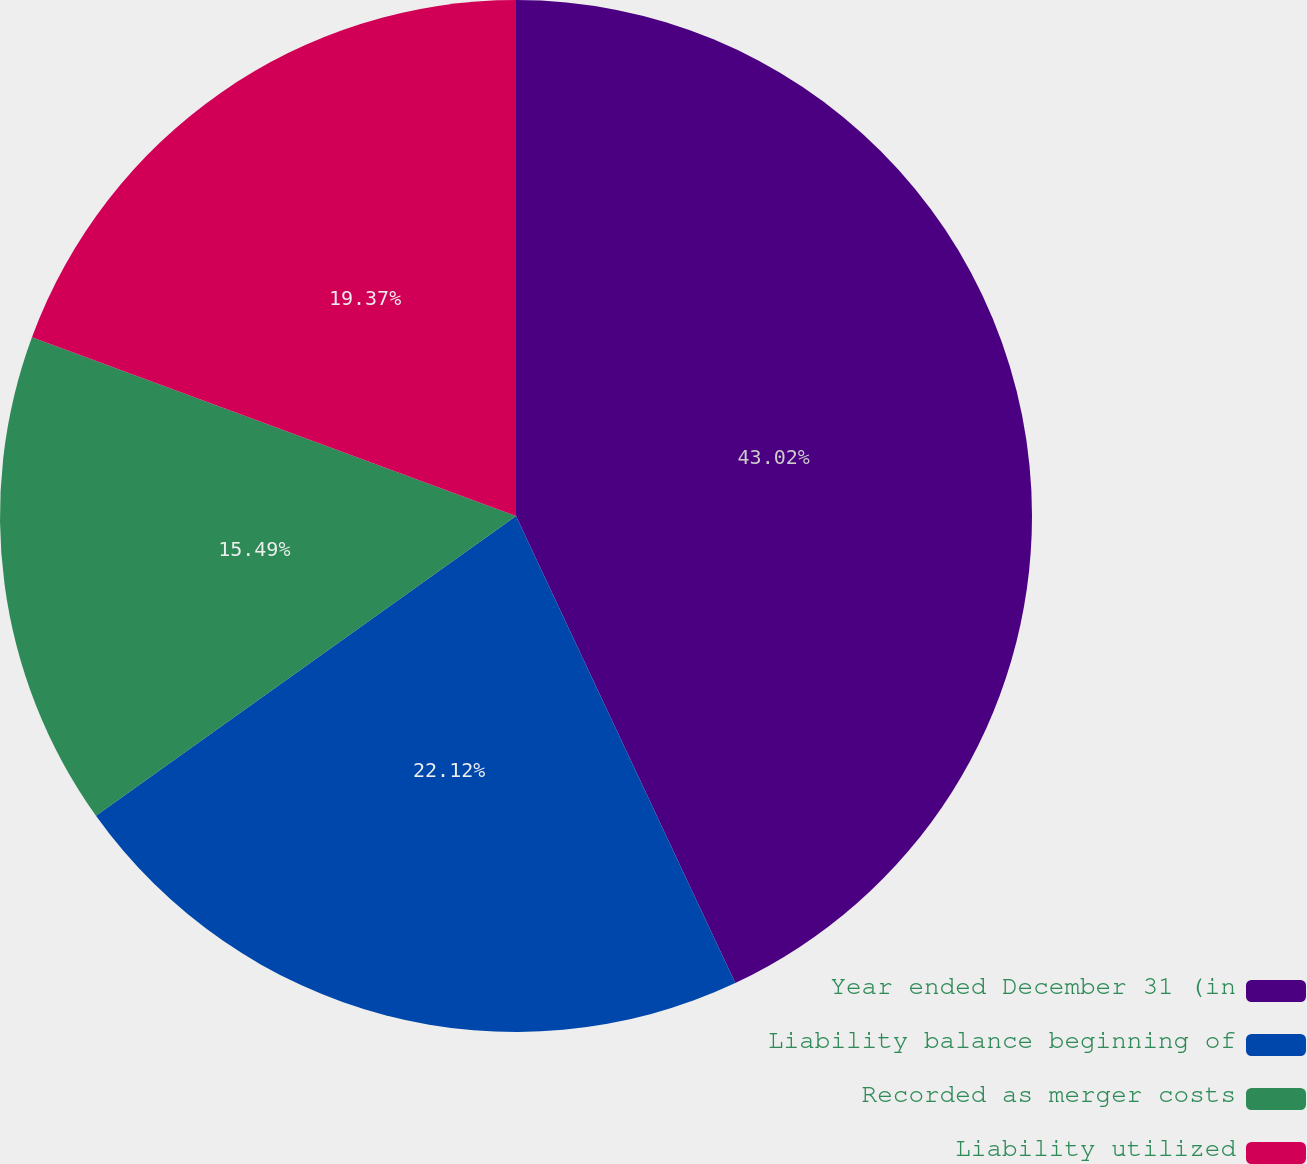<chart> <loc_0><loc_0><loc_500><loc_500><pie_chart><fcel>Year ended December 31 (in<fcel>Liability balance beginning of<fcel>Recorded as merger costs<fcel>Liability utilized<nl><fcel>43.01%<fcel>22.12%<fcel>15.49%<fcel>19.37%<nl></chart> 